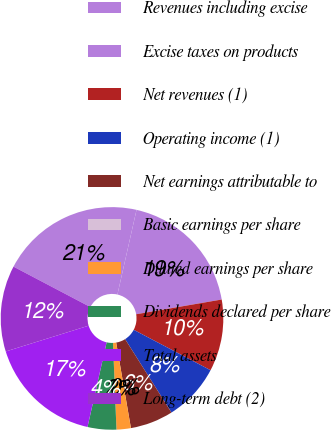Convert chart. <chart><loc_0><loc_0><loc_500><loc_500><pie_chart><fcel>Revenues including excise<fcel>Excise taxes on products<fcel>Net revenues (1)<fcel>Operating income (1)<fcel>Net earnings attributable to<fcel>Basic earnings per share<fcel>Diluted earnings per share<fcel>Dividends declared per share<fcel>Total assets<fcel>Long-term debt (2)<nl><fcel>20.83%<fcel>18.75%<fcel>10.42%<fcel>8.33%<fcel>6.25%<fcel>0.0%<fcel>2.08%<fcel>4.17%<fcel>16.67%<fcel>12.5%<nl></chart> 